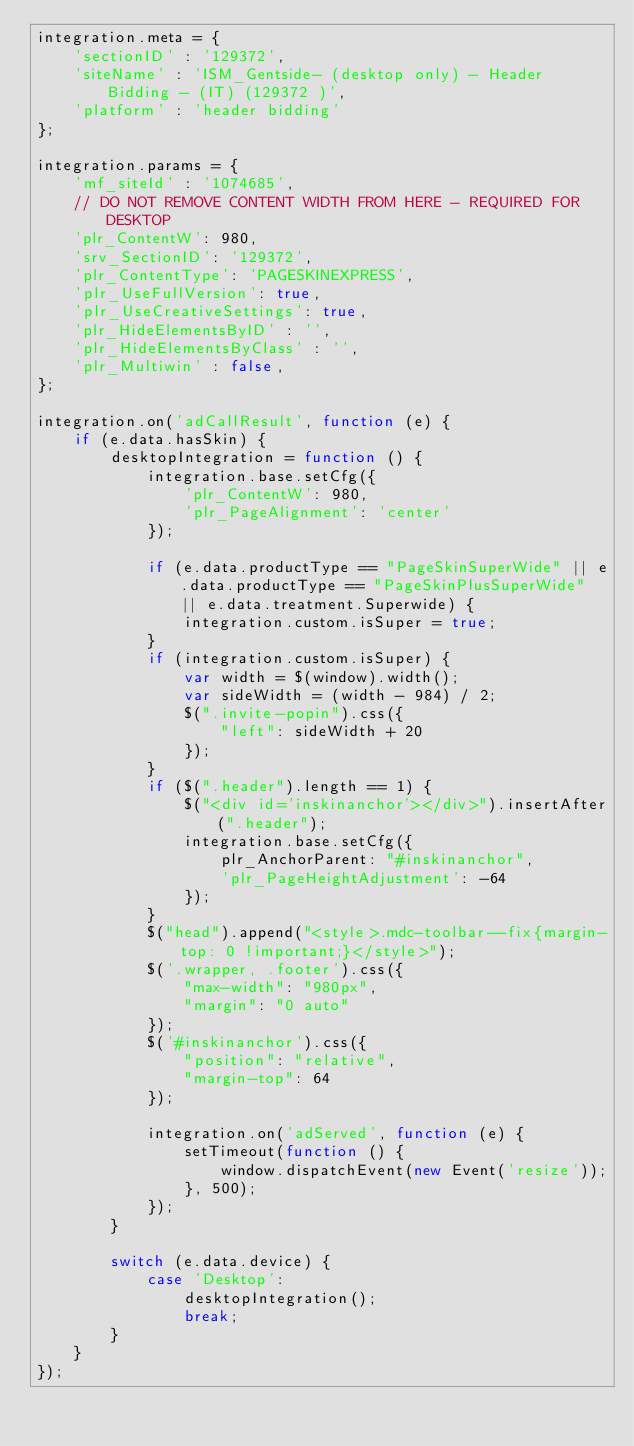Convert code to text. <code><loc_0><loc_0><loc_500><loc_500><_JavaScript_>integration.meta = {
    'sectionID' : '129372',
    'siteName' : 'ISM_Gentside- (desktop only) - Header Bidding - (IT) (129372 )',
    'platform' : 'header bidding'
};

integration.params = {
    'mf_siteId' : '1074685',
    // DO NOT REMOVE CONTENT WIDTH FROM HERE - REQUIRED FOR DESKTOP
    'plr_ContentW': 980,
    'srv_SectionID': '129372',
    'plr_ContentType': 'PAGESKINEXPRESS',
    'plr_UseFullVersion': true,
    'plr_UseCreativeSettings': true,
    'plr_HideElementsByID' : '',
    'plr_HideElementsByClass' : '',
    'plr_Multiwin' : false,
};

integration.on('adCallResult', function (e) {
    if (e.data.hasSkin) {
        desktopIntegration = function () {
            integration.base.setCfg({
                'plr_ContentW': 980,
                'plr_PageAlignment': 'center'
            });

            if (e.data.productType == "PageSkinSuperWide" || e.data.productType == "PageSkinPlusSuperWide" || e.data.treatment.Superwide) {
                integration.custom.isSuper = true;
            }
            if (integration.custom.isSuper) {
                var width = $(window).width();
                var sideWidth = (width - 984) / 2;
                $(".invite-popin").css({
                    "left": sideWidth + 20
                });
            }
            if ($(".header").length == 1) {
                $("<div id='inskinanchor'></div>").insertAfter(".header");
                integration.base.setCfg({
                    plr_AnchorParent: "#inskinanchor",
                    'plr_PageHeightAdjustment': -64
                });
            }
            $("head").append("<style>.mdc-toolbar--fix{margin-top: 0 !important;}</style>");
            $('.wrapper, .footer').css({
                "max-width": "980px",
                "margin": "0 auto"
            });
            $('#inskinanchor').css({
                "position": "relative",
                "margin-top": 64
            });

            integration.on('adServed', function (e) {
                setTimeout(function () {
                    window.dispatchEvent(new Event('resize'));
                }, 500);
            });
        }

        switch (e.data.device) {
            case 'Desktop':
                desktopIntegration();
                break;
        }
    }
});

</code> 